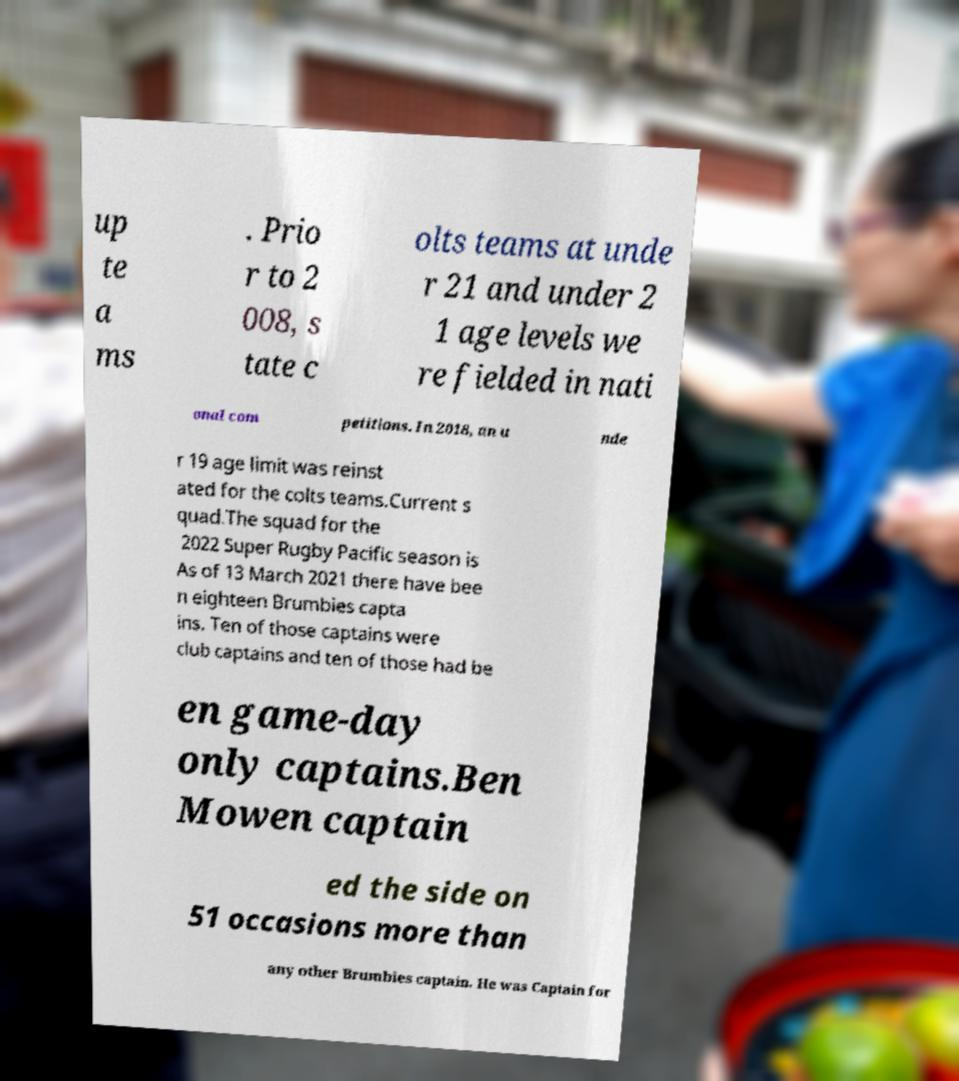Please identify and transcribe the text found in this image. up te a ms . Prio r to 2 008, s tate c olts teams at unde r 21 and under 2 1 age levels we re fielded in nati onal com petitions. In 2018, an u nde r 19 age limit was reinst ated for the colts teams.Current s quad.The squad for the 2022 Super Rugby Pacific season is As of 13 March 2021 there have bee n eighteen Brumbies capta ins. Ten of those captains were club captains and ten of those had be en game-day only captains.Ben Mowen captain ed the side on 51 occasions more than any other Brumbies captain. He was Captain for 